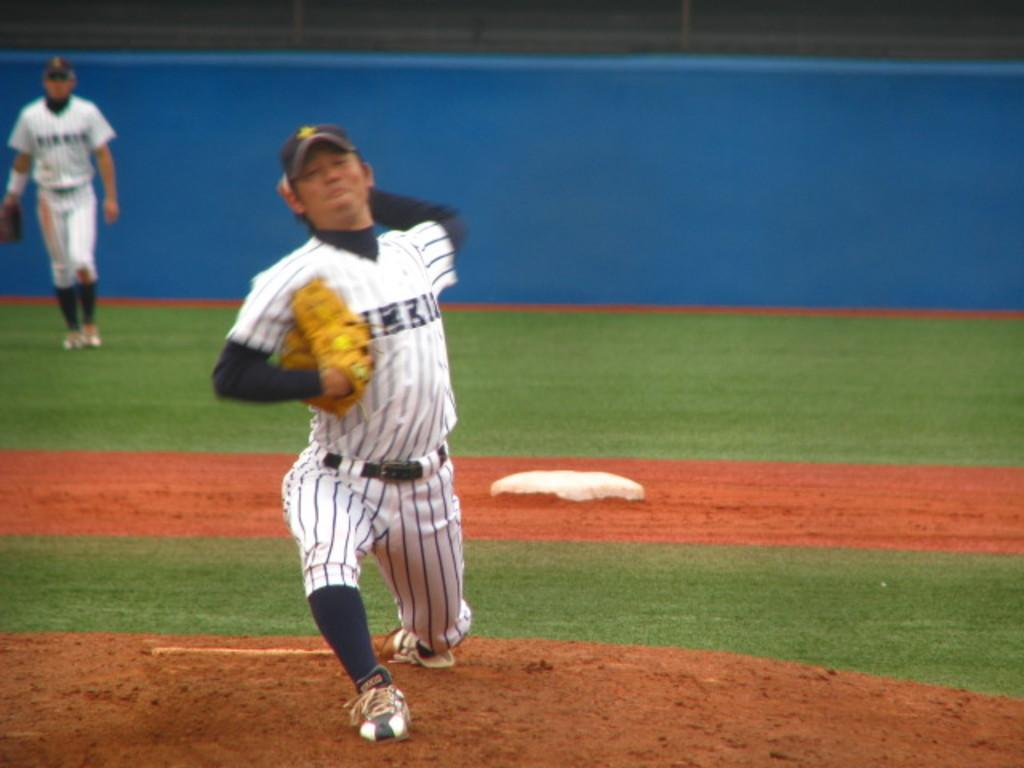How many people are in the image? There are two persons on the ground in the image. What type of surface are the people on? A: There is grass visible in the image. What can be seen in the background of the image? There is a wall in the background of the image. What type of ear is visible on the person in the image? There is no ear visible on the person in the image, as the image does not show their faces. Can you tell me how many kettles are present in the image? There are no kettles present in the image. 